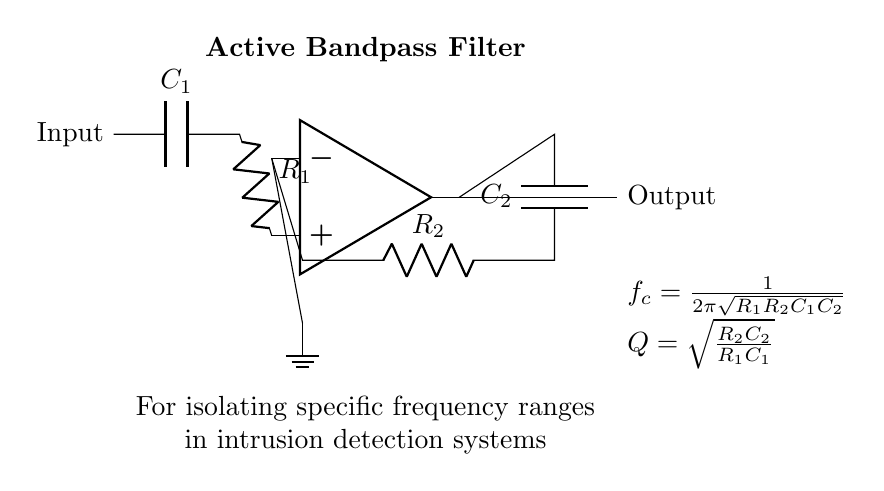What type of filter does this circuit represent? The circuit is labeled as an "Active Bandpass Filter," which suggests its purpose is to allow a specific range of frequencies to pass while attenuating frequencies outside this range.
Answer: Active Bandpass Filter What component provides feedback in this circuit? The feedback is supplied by the resistor labeled R2 and the capacitor labeled C2. These components connect from the output of the op-amp back to the inverting input, forming the feedback loop necessary for the bandpass characteristics.
Answer: R2 and C2 What is the function of capacitor C1? Capacitor C1, in combination with resistor R1, defines the high-frequency cutoff point of the filter by blocking DC signals and allowing AC signals above a certain frequency to pass to the non-inverting input of the op-amp.
Answer: High-frequency cutoff How is the cutoff frequency (f_c) calculated? The cutoff frequency, f_c, is determined using the formula \( f_c = \frac{1}{2\pi\sqrt{R_1R_2C_1C_2}} \), which indicates the relationship among the resistors and capacitors in setting the filter's response curve.
Answer: f_c formula What does the quality factor (Q) indicate in this filter? The quality factor Q indicates the selectivity of the filter and is calculated using the formula \( Q = \sqrt{\frac{R_2C_2}{R_1C_1}} \). A higher Q implies a narrower bandwidth and sharper resonance around the center frequency, enhancing the isolation of specific frequency ranges.
Answer: Selectivity What role does the op-amp serve in this filter? The op-amp amplifies the signals passing through the filter circuit, enhancing the output signal's amplitude after the filtering process has occurred. This makes the filter suitable for applications where signal strength is crucial after frequency selection.
Answer: Amplification Where is the ground connected in this circuit? The ground is connected at the inverting terminal of the op-amp, indicated by the ground symbol, providing a reference point for the circuit and ensuring stability in the operation of the op-amp.
Answer: Inverting terminal 